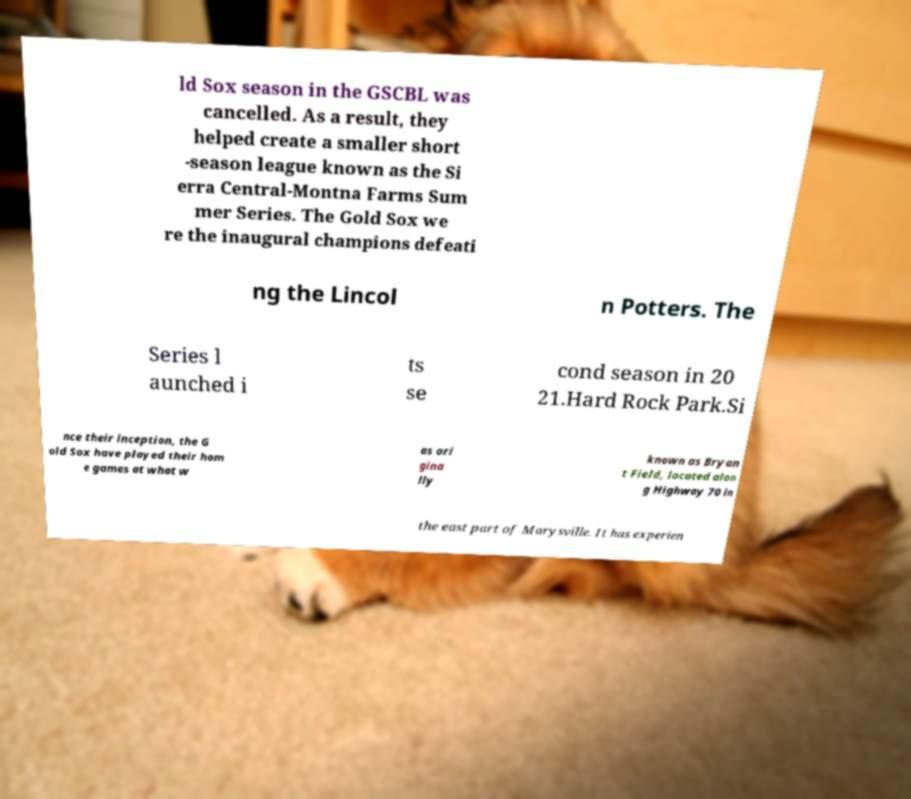Can you read and provide the text displayed in the image?This photo seems to have some interesting text. Can you extract and type it out for me? ld Sox season in the GSCBL was cancelled. As a result, they helped create a smaller short -season league known as the Si erra Central-Montna Farms Sum mer Series. The Gold Sox we re the inaugural champions defeati ng the Lincol n Potters. The Series l aunched i ts se cond season in 20 21.Hard Rock Park.Si nce their inception, the G old Sox have played their hom e games at what w as ori gina lly known as Bryan t Field, located alon g Highway 70 in the east part of Marysville. It has experien 